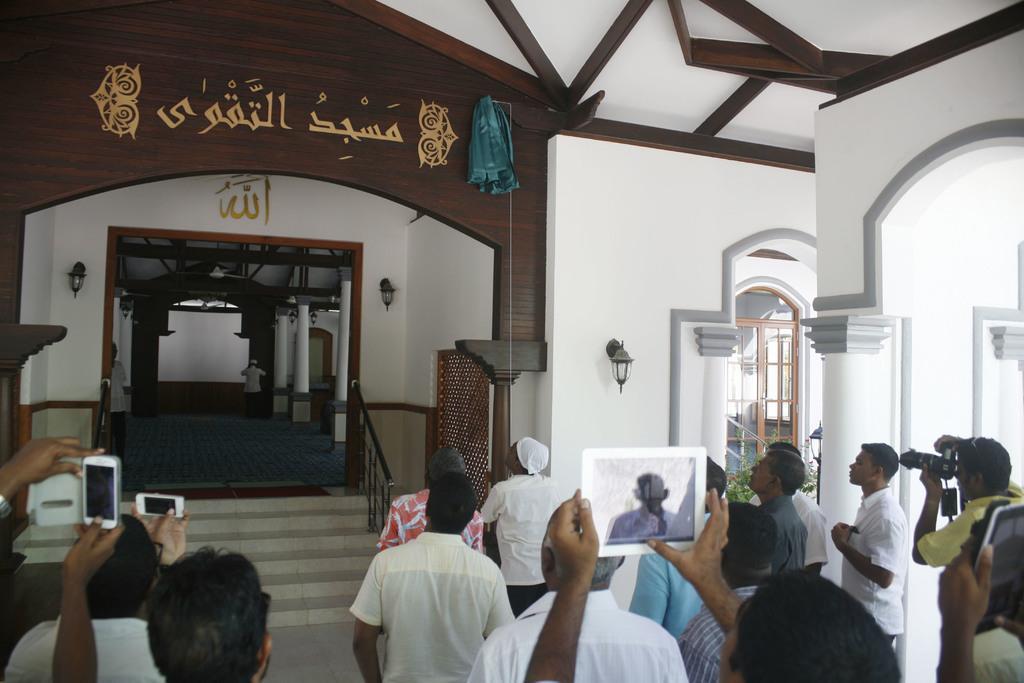How would you summarize this image in a sentence or two? In the foreground of the picture we can see people, electronic gadgets, camera and other things. In the middle of the picture we can see staircase, railing, wall, lamp, board, cloth and other objects. In the background there are pillars, people and other objects. On the right we can see pillar and window. 